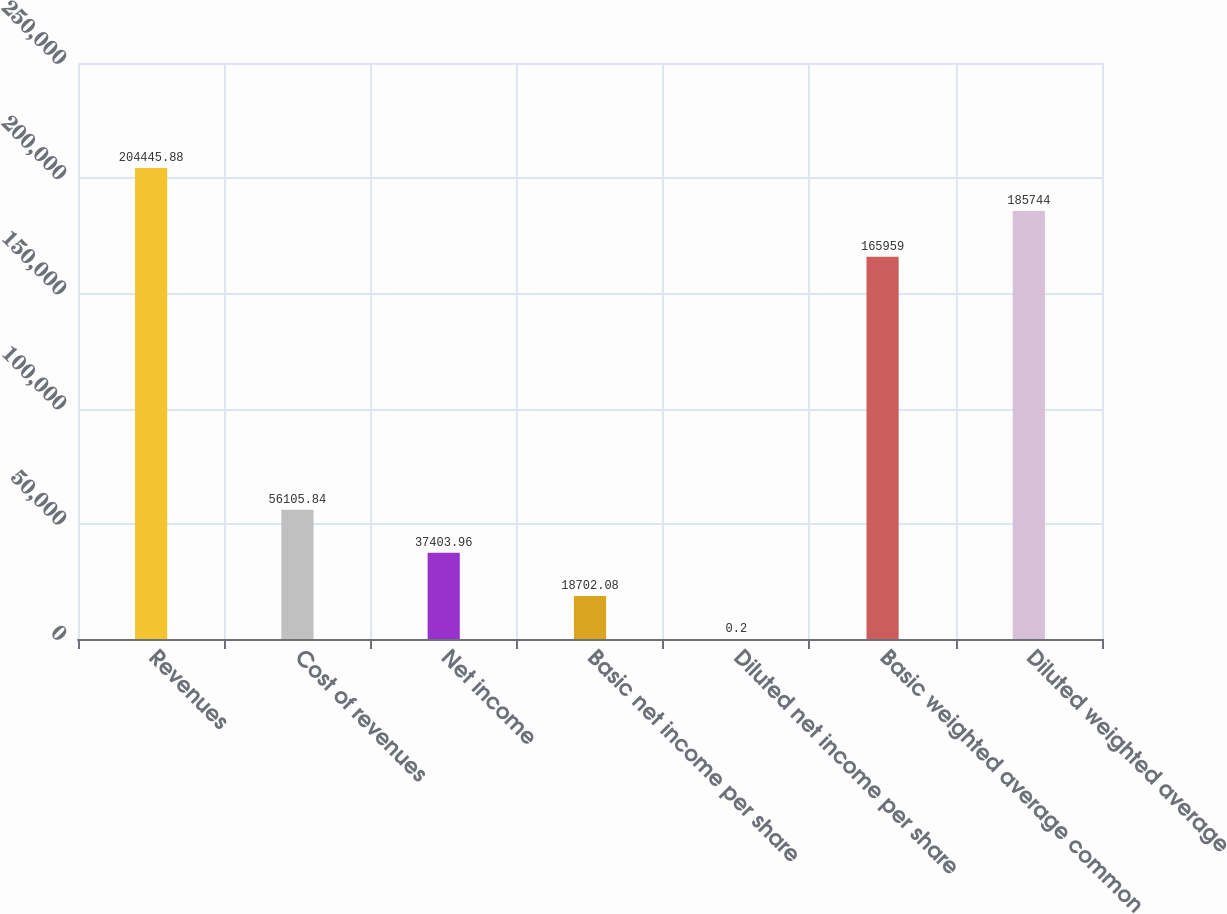<chart> <loc_0><loc_0><loc_500><loc_500><bar_chart><fcel>Revenues<fcel>Cost of revenues<fcel>Net income<fcel>Basic net income per share<fcel>Diluted net income per share<fcel>Basic weighted average common<fcel>Diluted weighted average<nl><fcel>204446<fcel>56105.8<fcel>37404<fcel>18702.1<fcel>0.2<fcel>165959<fcel>185744<nl></chart> 